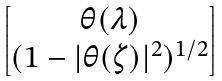<formula> <loc_0><loc_0><loc_500><loc_500>\begin{bmatrix} \theta ( \lambda ) \\ ( 1 - | \theta ( \zeta ) | ^ { 2 } ) ^ { 1 / 2 } \end{bmatrix}</formula> 